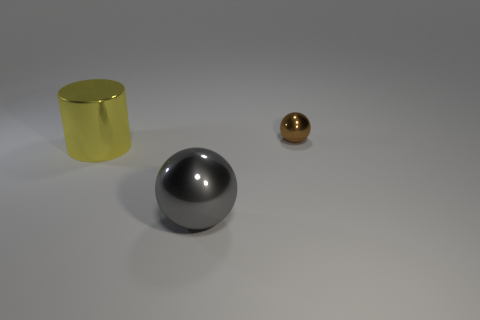There is a ball behind the big shiny cylinder behind the big sphere; how big is it?
Your answer should be very brief. Small. What material is the large thing to the left of the gray ball?
Your response must be concise. Metal. There is a brown ball that is the same material as the yellow cylinder; what is its size?
Offer a terse response. Small. What number of yellow objects are the same shape as the brown metal object?
Offer a very short reply. 0. Do the big yellow metallic thing and the object that is on the right side of the gray metal object have the same shape?
Provide a short and direct response. No. Are there any spheres that have the same material as the big yellow thing?
Your response must be concise. Yes. Are there any other things that have the same material as the small brown thing?
Offer a very short reply. Yes. There is a large thing that is on the left side of the sphere that is on the left side of the tiny ball; what is it made of?
Make the answer very short. Metal. What size is the metallic thing behind the large shiny object that is to the left of the big metal thing that is in front of the yellow cylinder?
Your answer should be compact. Small. How many other things are the same shape as the gray metallic object?
Offer a very short reply. 1. 